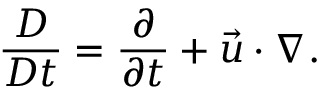Convert formula to latex. <formula><loc_0><loc_0><loc_500><loc_500>\frac { D } { D t } = \frac { \partial } { \partial t } + \vec { u } \cdot \nabla .</formula> 